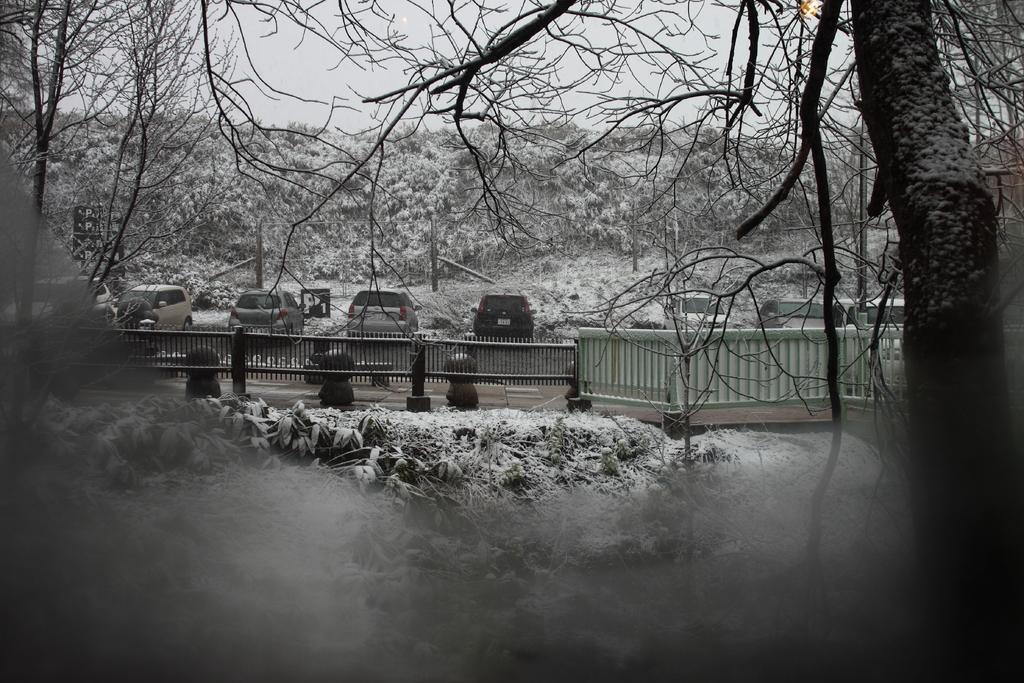In one or two sentences, can you explain what this image depicts? In the image it seems like there are some leaves in the foreground and behind the leaves there is a fencing, on the right side there is a tree and behind the fencing there are vehicles and in the background there are a lot of trees. 